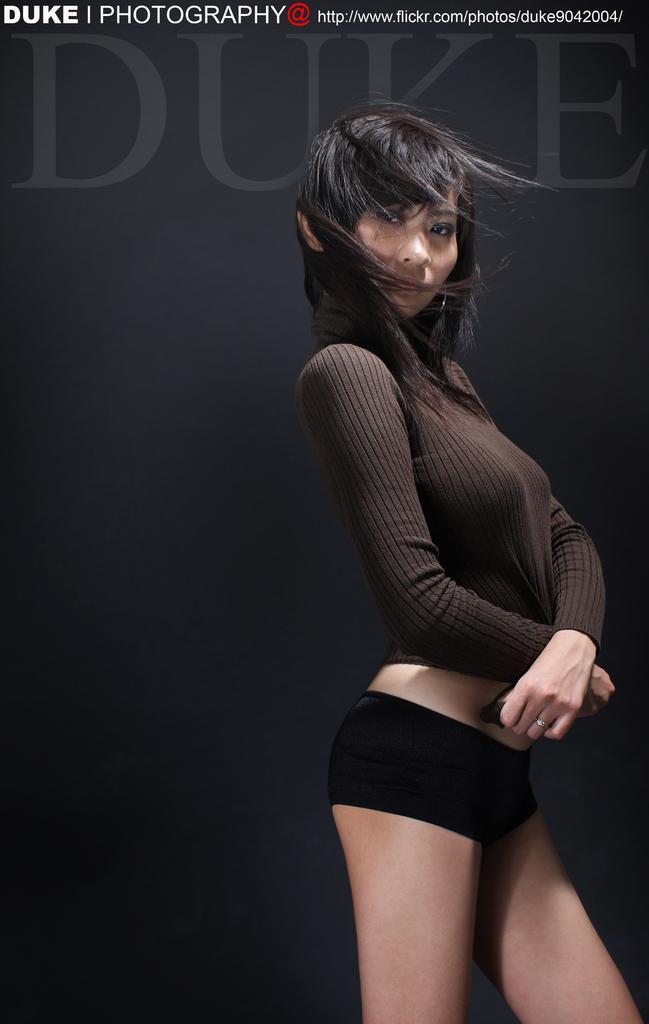In one or two sentences, can you explain what this image depicts? In this image a beautiful lady is standing ,she is wearing a black color T-shirt and black color shot. 